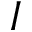Convert formula to latex. <formula><loc_0><loc_0><loc_500><loc_500>I</formula> 